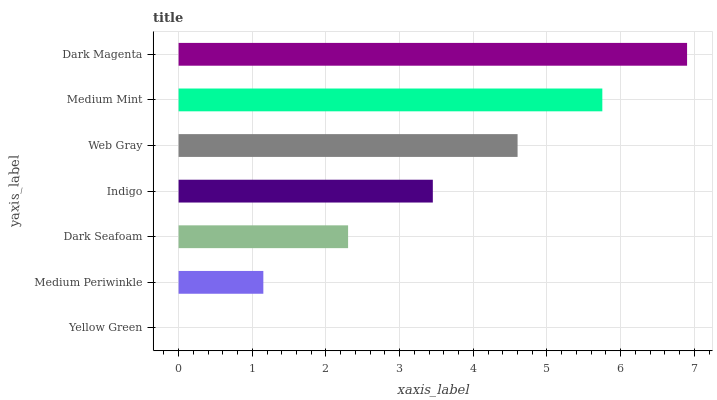Is Yellow Green the minimum?
Answer yes or no. Yes. Is Dark Magenta the maximum?
Answer yes or no. Yes. Is Medium Periwinkle the minimum?
Answer yes or no. No. Is Medium Periwinkle the maximum?
Answer yes or no. No. Is Medium Periwinkle greater than Yellow Green?
Answer yes or no. Yes. Is Yellow Green less than Medium Periwinkle?
Answer yes or no. Yes. Is Yellow Green greater than Medium Periwinkle?
Answer yes or no. No. Is Medium Periwinkle less than Yellow Green?
Answer yes or no. No. Is Indigo the high median?
Answer yes or no. Yes. Is Indigo the low median?
Answer yes or no. Yes. Is Medium Mint the high median?
Answer yes or no. No. Is Medium Periwinkle the low median?
Answer yes or no. No. 